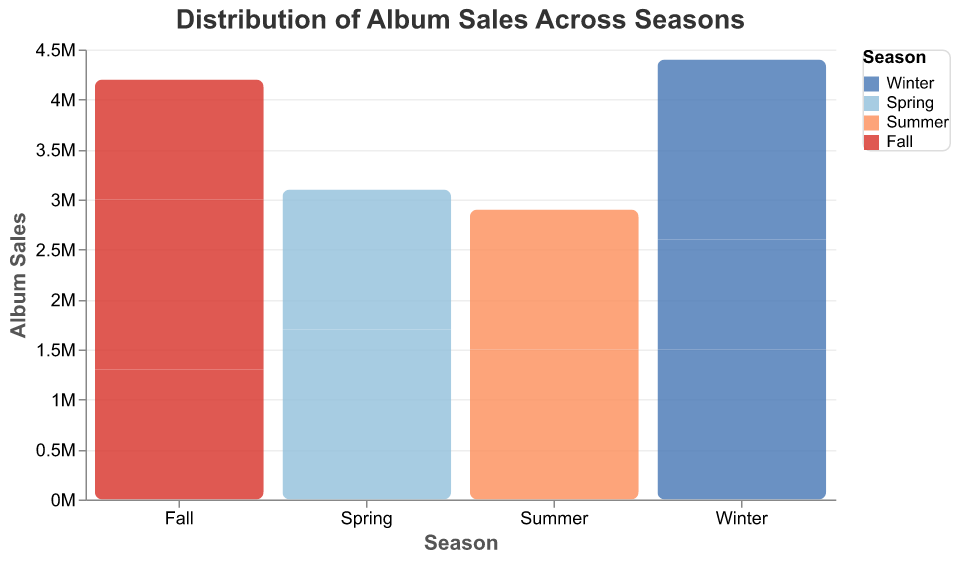Which season shows the highest album sales? Winter shows the highest album sales with Adele's "25" selling 1,800,000 copies.
Answer: Winter How many albums have sales equal to or greater than 1,500,000? Taylor Swift's "Folklore" in Winter, Adele's "25" in Winter, Ed Sheeran's "Divide" in Spring, The Weeknd's "After Hours" in Summer, and BTS's "Map of the Soul: 7" in Fall have sales equal to or greater than 1,500,000. That's 5 albums.
Answer: 5 Which artist has the highest sales in Spring? Ed Sheeran has the highest sales in Spring with "Divide" selling 1,700,000 copies.
Answer: Ed Sheeran Is summer the season with the lowest album sales overall? No, the lowest individual album sales observed are in Fall with Lady Gaga's "Chromatica" selling 1,200,000 copies. However, Summer does not have notably lower overall sales than Fall.
Answer: No Which season has the most variety in terms of different artists? In terms of the number of different artists, Winter, Spring, and Summer each have two different artists. Fall, however, has three different artists (Bruno Mars, BTS, Lady Gaga). So, Fall has the most variety.
Answer: Fall What is the difference in sales between the highest and lowest selling albums? The highest selling album is Adele's "25" with 1,800,000 copies, and the lowest is Lady Gaga's "Chromatica" with 1,200,000 copies. The difference is 1,800,000 - 1,200,000 = 600,000 copies.
Answer: 600,000 What is the total sales figure for albums released in Summer? The total sales figure for albums released in Summer is 1,500,000 (The Weeknd) + 1,400,000 (Dua Lipa) = 2,900,000.
Answer: 2,900,000 Which artist's album in Fall has sales exceeding 1,500,000? BTS's album "Map of the Soul: 7" in Fall has 1,700,000 sales, which exceeds 1,500,000.
Answer: BTS 